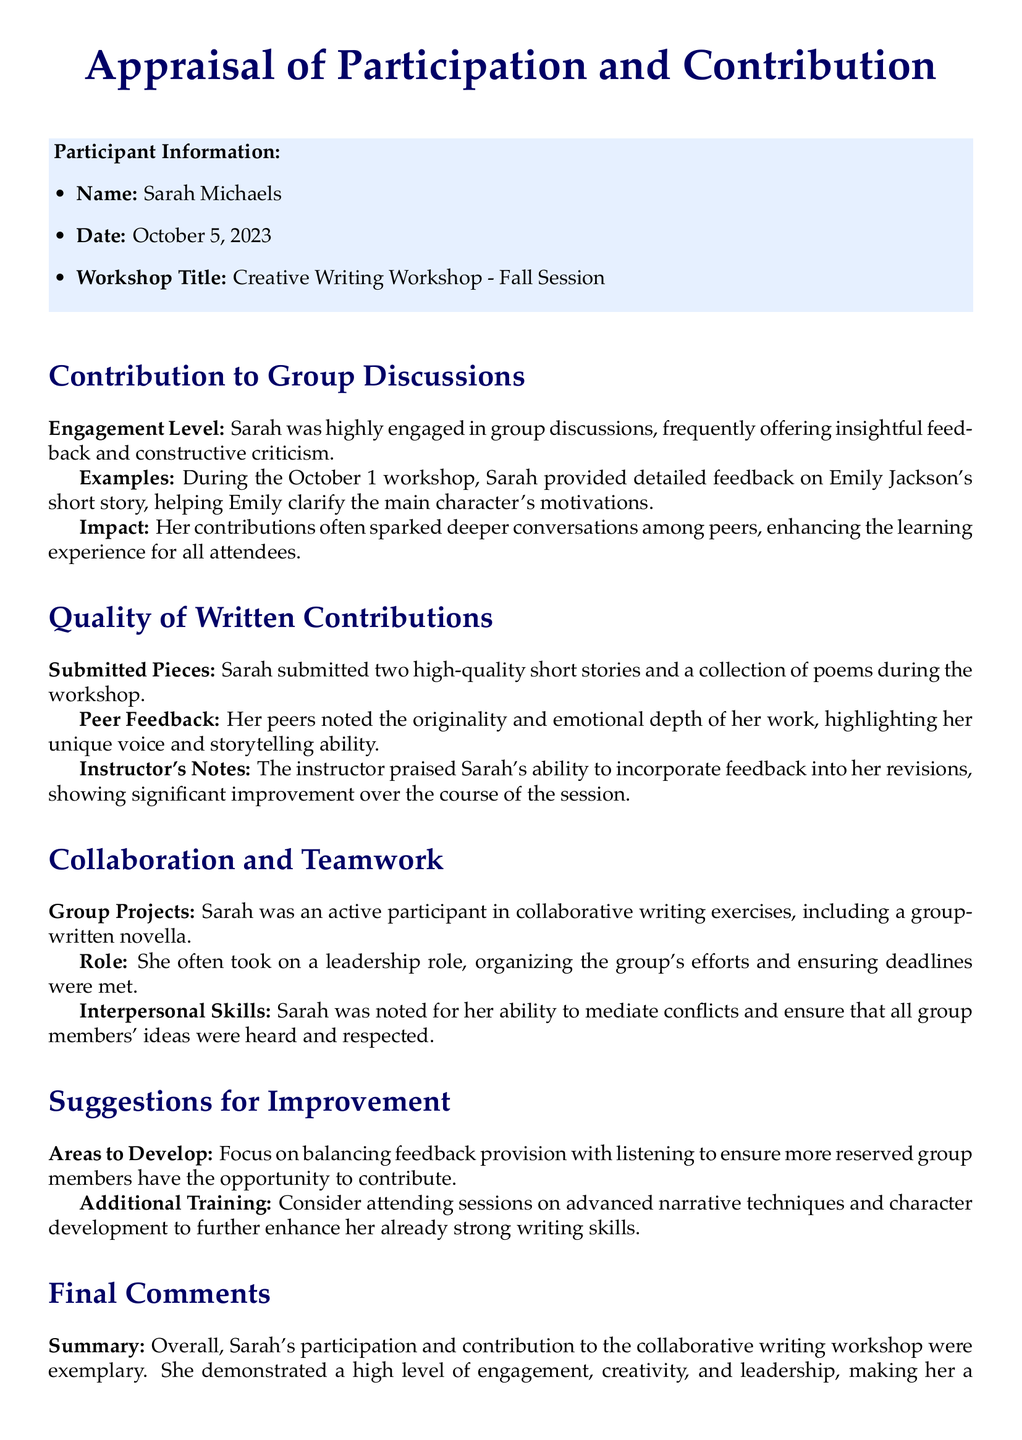What is the name of the participant? The participant's name is listed at the top of the appraisal form.
Answer: Sarah Michaels What is the date of the appraisal? The date is mentioned in the participant information section of the form.
Answer: October 5, 2023 What workshop title is associated with the appraisal? The workshop title is specified in the participant information section.
Answer: Creative Writing Workshop - Fall Session How many short stories did Sarah submit? The number of short stories submitted is mentioned in the section about written contributions.
Answer: Two What did Sarah help Emily clarify in her feedback? The specific aspect of Emily's story that Sarah helped clarify is indicated in the evaluation of group discussions.
Answer: Main character's motivations What role did Sarah often take in group projects? This information is provided in the collaboration and teamwork section of the document.
Answer: Leadership role What area has been suggested for Sarah to develop? The suggestions for improvement section lists areas for growth.
Answer: Balancing feedback provision with listening What did the instructor praise Sarah for? The praise from the instructor is mentioned in the quality of written contributions section.
Answer: Incorporating feedback into her revisions What was the overall summary of Sarah's contribution? The final comments sum up Sarah's participation and contribution in the workshop.
Answer: Exemplary 